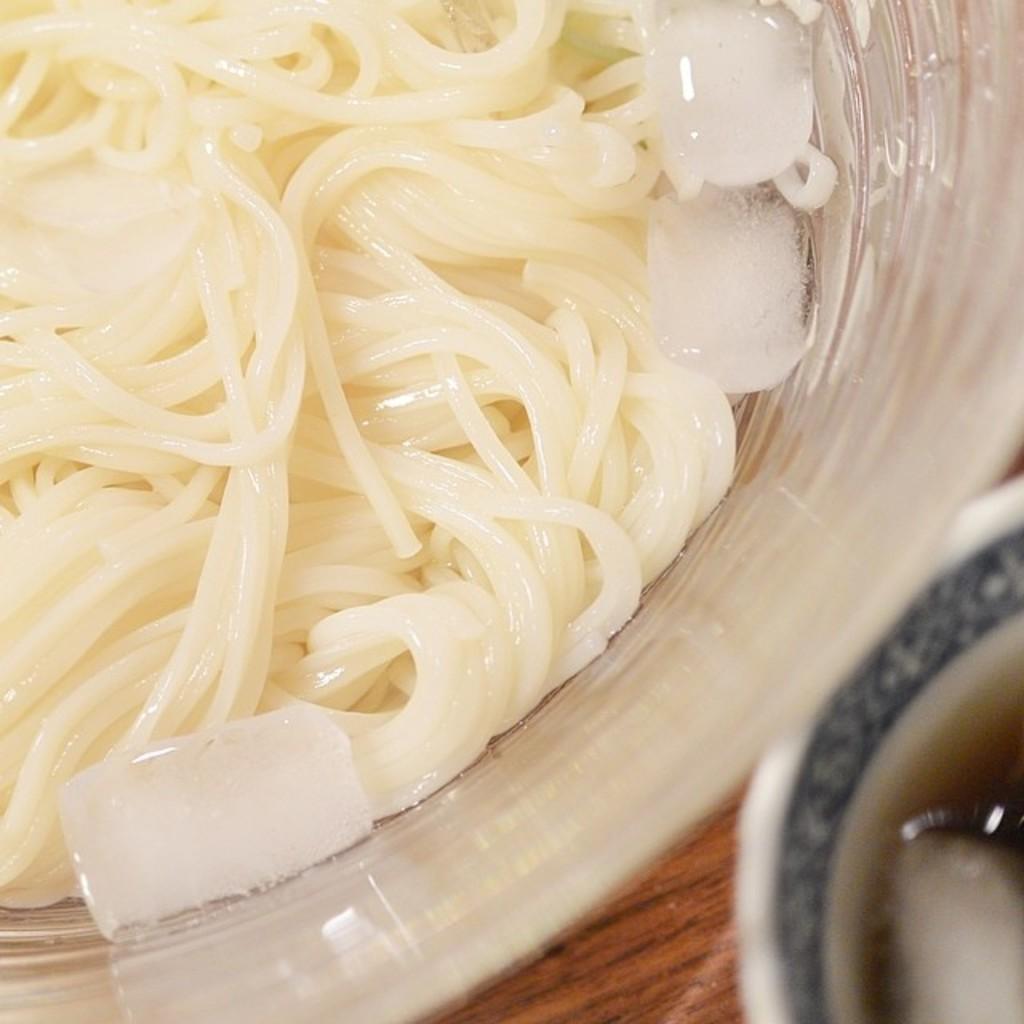How would you summarize this image in a sentence or two? In this image we can see food items in a bowl. In the bottom right we can see a cup with liquid in it. At the bottom we can see a wooden surface. 